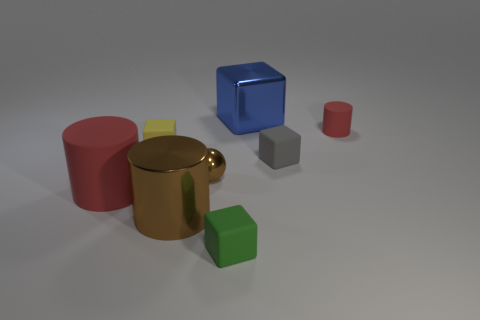Subtract 1 cubes. How many cubes are left? 3 Add 2 blue cubes. How many objects exist? 10 Subtract all balls. How many objects are left? 7 Add 4 blocks. How many blocks are left? 8 Add 8 small brown metal things. How many small brown metal things exist? 9 Subtract 0 gray spheres. How many objects are left? 8 Subtract all large blue cubes. Subtract all small rubber cubes. How many objects are left? 4 